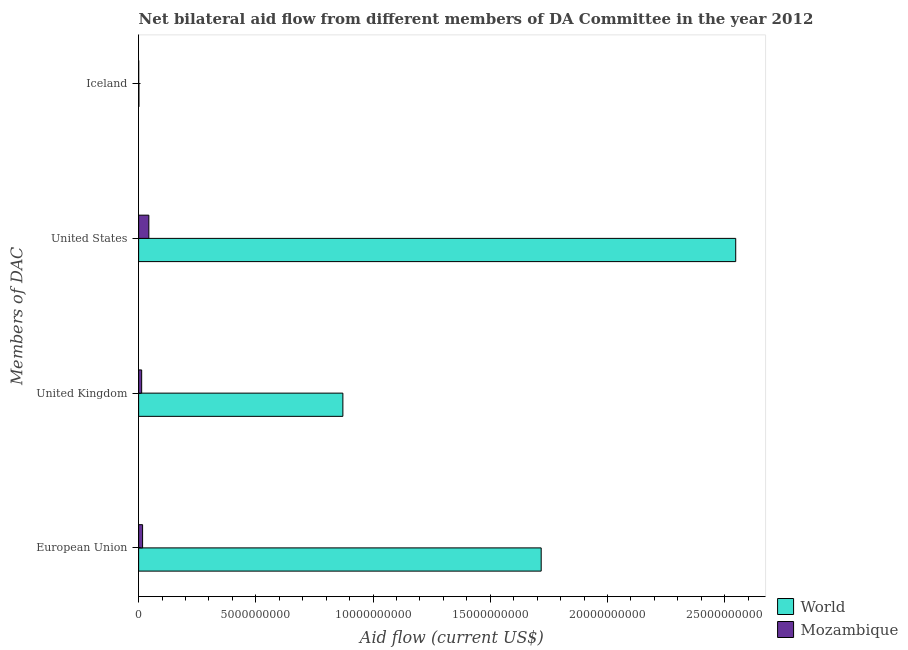How many different coloured bars are there?
Your answer should be very brief. 2. Are the number of bars per tick equal to the number of legend labels?
Offer a terse response. Yes. What is the label of the 1st group of bars from the top?
Your answer should be compact. Iceland. What is the amount of aid given by iceland in Mozambique?
Keep it short and to the point. 2.31e+06. Across all countries, what is the maximum amount of aid given by us?
Your answer should be very brief. 2.55e+1. Across all countries, what is the minimum amount of aid given by us?
Your answer should be very brief. 4.35e+08. In which country was the amount of aid given by uk minimum?
Provide a succinct answer. Mozambique. What is the total amount of aid given by uk in the graph?
Your answer should be compact. 8.84e+09. What is the difference between the amount of aid given by eu in World and that in Mozambique?
Offer a terse response. 1.70e+1. What is the difference between the amount of aid given by eu in Mozambique and the amount of aid given by uk in World?
Offer a very short reply. -8.54e+09. What is the average amount of aid given by uk per country?
Keep it short and to the point. 4.42e+09. What is the difference between the amount of aid given by iceland and amount of aid given by us in World?
Offer a very short reply. -2.55e+1. What is the ratio of the amount of aid given by uk in Mozambique to that in World?
Ensure brevity in your answer.  0.01. Is the difference between the amount of aid given by iceland in Mozambique and World greater than the difference between the amount of aid given by us in Mozambique and World?
Ensure brevity in your answer.  Yes. What is the difference between the highest and the second highest amount of aid given by us?
Offer a terse response. 2.50e+1. What is the difference between the highest and the lowest amount of aid given by eu?
Give a very brief answer. 1.70e+1. Is it the case that in every country, the sum of the amount of aid given by uk and amount of aid given by iceland is greater than the sum of amount of aid given by eu and amount of aid given by us?
Provide a short and direct response. No. What does the 1st bar from the bottom in European Union represents?
Offer a terse response. World. Are all the bars in the graph horizontal?
Provide a succinct answer. Yes. How many countries are there in the graph?
Your response must be concise. 2. What is the difference between two consecutive major ticks on the X-axis?
Keep it short and to the point. 5.00e+09. Are the values on the major ticks of X-axis written in scientific E-notation?
Offer a terse response. No. How are the legend labels stacked?
Make the answer very short. Vertical. What is the title of the graph?
Give a very brief answer. Net bilateral aid flow from different members of DA Committee in the year 2012. Does "Armenia" appear as one of the legend labels in the graph?
Ensure brevity in your answer.  No. What is the label or title of the X-axis?
Make the answer very short. Aid flow (current US$). What is the label or title of the Y-axis?
Ensure brevity in your answer.  Members of DAC. What is the Aid flow (current US$) of World in European Union?
Ensure brevity in your answer.  1.72e+1. What is the Aid flow (current US$) in Mozambique in European Union?
Your answer should be compact. 1.69e+08. What is the Aid flow (current US$) in World in United Kingdom?
Your response must be concise. 8.71e+09. What is the Aid flow (current US$) in Mozambique in United Kingdom?
Your response must be concise. 1.30e+08. What is the Aid flow (current US$) of World in United States?
Your response must be concise. 2.55e+1. What is the Aid flow (current US$) in Mozambique in United States?
Your response must be concise. 4.35e+08. What is the Aid flow (current US$) in World in Iceland?
Ensure brevity in your answer.  1.24e+07. What is the Aid flow (current US$) in Mozambique in Iceland?
Your answer should be compact. 2.31e+06. Across all Members of DAC, what is the maximum Aid flow (current US$) of World?
Give a very brief answer. 2.55e+1. Across all Members of DAC, what is the maximum Aid flow (current US$) of Mozambique?
Give a very brief answer. 4.35e+08. Across all Members of DAC, what is the minimum Aid flow (current US$) in World?
Give a very brief answer. 1.24e+07. Across all Members of DAC, what is the minimum Aid flow (current US$) in Mozambique?
Offer a very short reply. 2.31e+06. What is the total Aid flow (current US$) of World in the graph?
Your answer should be very brief. 5.14e+1. What is the total Aid flow (current US$) in Mozambique in the graph?
Your answer should be very brief. 7.37e+08. What is the difference between the Aid flow (current US$) in World in European Union and that in United Kingdom?
Give a very brief answer. 8.46e+09. What is the difference between the Aid flow (current US$) of Mozambique in European Union and that in United Kingdom?
Your response must be concise. 3.96e+07. What is the difference between the Aid flow (current US$) in World in European Union and that in United States?
Keep it short and to the point. -8.30e+09. What is the difference between the Aid flow (current US$) of Mozambique in European Union and that in United States?
Your answer should be very brief. -2.66e+08. What is the difference between the Aid flow (current US$) of World in European Union and that in Iceland?
Make the answer very short. 1.72e+1. What is the difference between the Aid flow (current US$) of Mozambique in European Union and that in Iceland?
Offer a very short reply. 1.67e+08. What is the difference between the Aid flow (current US$) of World in United Kingdom and that in United States?
Provide a short and direct response. -1.68e+1. What is the difference between the Aid flow (current US$) in Mozambique in United Kingdom and that in United States?
Your response must be concise. -3.06e+08. What is the difference between the Aid flow (current US$) of World in United Kingdom and that in Iceland?
Ensure brevity in your answer.  8.70e+09. What is the difference between the Aid flow (current US$) in Mozambique in United Kingdom and that in Iceland?
Give a very brief answer. 1.27e+08. What is the difference between the Aid flow (current US$) in World in United States and that in Iceland?
Give a very brief answer. 2.55e+1. What is the difference between the Aid flow (current US$) of Mozambique in United States and that in Iceland?
Provide a succinct answer. 4.33e+08. What is the difference between the Aid flow (current US$) in World in European Union and the Aid flow (current US$) in Mozambique in United Kingdom?
Your response must be concise. 1.70e+1. What is the difference between the Aid flow (current US$) of World in European Union and the Aid flow (current US$) of Mozambique in United States?
Ensure brevity in your answer.  1.67e+1. What is the difference between the Aid flow (current US$) in World in European Union and the Aid flow (current US$) in Mozambique in Iceland?
Offer a very short reply. 1.72e+1. What is the difference between the Aid flow (current US$) in World in United Kingdom and the Aid flow (current US$) in Mozambique in United States?
Keep it short and to the point. 8.28e+09. What is the difference between the Aid flow (current US$) of World in United Kingdom and the Aid flow (current US$) of Mozambique in Iceland?
Make the answer very short. 8.71e+09. What is the difference between the Aid flow (current US$) of World in United States and the Aid flow (current US$) of Mozambique in Iceland?
Your answer should be compact. 2.55e+1. What is the average Aid flow (current US$) of World per Members of DAC?
Ensure brevity in your answer.  1.28e+1. What is the average Aid flow (current US$) in Mozambique per Members of DAC?
Your response must be concise. 1.84e+08. What is the difference between the Aid flow (current US$) of World and Aid flow (current US$) of Mozambique in European Union?
Give a very brief answer. 1.70e+1. What is the difference between the Aid flow (current US$) of World and Aid flow (current US$) of Mozambique in United Kingdom?
Offer a very short reply. 8.58e+09. What is the difference between the Aid flow (current US$) in World and Aid flow (current US$) in Mozambique in United States?
Your response must be concise. 2.50e+1. What is the difference between the Aid flow (current US$) in World and Aid flow (current US$) in Mozambique in Iceland?
Your answer should be compact. 1.00e+07. What is the ratio of the Aid flow (current US$) of World in European Union to that in United Kingdom?
Offer a terse response. 1.97. What is the ratio of the Aid flow (current US$) of Mozambique in European Union to that in United Kingdom?
Offer a terse response. 1.31. What is the ratio of the Aid flow (current US$) of World in European Union to that in United States?
Your answer should be very brief. 0.67. What is the ratio of the Aid flow (current US$) in Mozambique in European Union to that in United States?
Your answer should be very brief. 0.39. What is the ratio of the Aid flow (current US$) in World in European Union to that in Iceland?
Offer a terse response. 1389.38. What is the ratio of the Aid flow (current US$) in Mozambique in European Union to that in Iceland?
Keep it short and to the point. 73.23. What is the ratio of the Aid flow (current US$) of World in United Kingdom to that in United States?
Your answer should be very brief. 0.34. What is the ratio of the Aid flow (current US$) in Mozambique in United Kingdom to that in United States?
Your answer should be very brief. 0.3. What is the ratio of the Aid flow (current US$) of World in United Kingdom to that in Iceland?
Provide a succinct answer. 704.93. What is the ratio of the Aid flow (current US$) of Mozambique in United Kingdom to that in Iceland?
Provide a short and direct response. 56.1. What is the ratio of the Aid flow (current US$) in World in United States to that in Iceland?
Your response must be concise. 2060.77. What is the ratio of the Aid flow (current US$) in Mozambique in United States to that in Iceland?
Your answer should be very brief. 188.52. What is the difference between the highest and the second highest Aid flow (current US$) of World?
Keep it short and to the point. 8.30e+09. What is the difference between the highest and the second highest Aid flow (current US$) of Mozambique?
Offer a terse response. 2.66e+08. What is the difference between the highest and the lowest Aid flow (current US$) of World?
Your response must be concise. 2.55e+1. What is the difference between the highest and the lowest Aid flow (current US$) in Mozambique?
Offer a terse response. 4.33e+08. 